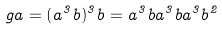<formula> <loc_0><loc_0><loc_500><loc_500>\ g a = ( a ^ { 3 } b ) ^ { 3 } b = a ^ { 3 } b a ^ { 3 } b a ^ { 3 } b ^ { 2 }</formula> 